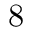<formula> <loc_0><loc_0><loc_500><loc_500>8</formula> 